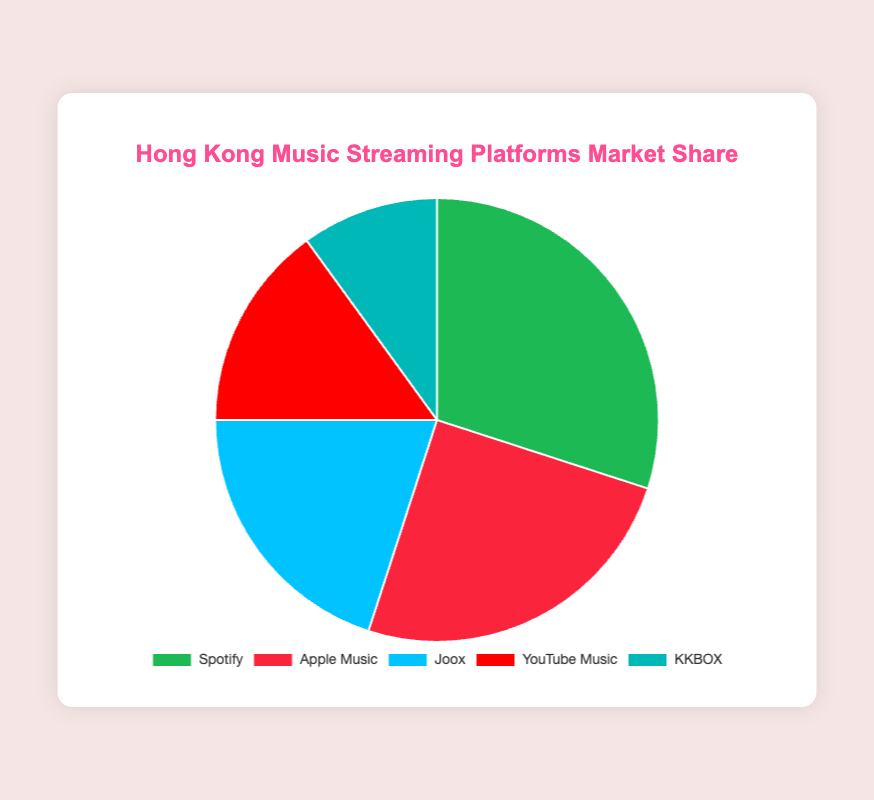What is the market share of Spotify? The pie chart shows the market share percentages for different music streaming platforms. Locate Spotify in the legend or chart, which shows a 30% market share.
Answer: 30% Which platform has the smallest market share, and what is it? Identify each platform's market share from the pie chart and compare them. KKBOX has the smallest market share at 10%.
Answer: KKBOX, 10% How much more market share does Spotify have compared to YouTube Music? Find the market shares for Spotify (30%) and YouTube Music (15%), then calculate the difference: 30% - 15% = 15%.
Answer: 15% What is the total market share of Joox and KKBOX combined? Add Joox's market share (20%) and KKBOX's market share (10%): 20% + 10% = 30%.
Answer: 30% Which platform has the second-largest market share, and what is it? From the pie chart, observe the market shares in descending order. Apple Music has the second-largest share at 25%.
Answer: Apple Music, 25% Which two platforms have a combined market share equal to Spotify's? Find data points that sum to Spotify's 30%. Apple Music (25%) and KKBOX (10%) together have a 30% share.
Answer: Apple Music and KKBOX How does the market share of Apple Music compare to that of Joox? Compare the market shares given: Apple Music (25%) is greater than Joox (20%).
Answer: Apple Music > Joox What is the average market share of the five platforms? Sum the market shares (30% + 25% + 20% + 15% + 10%) = 100%, then divide by 5: 100% / 5 = 20%.
Answer: 20% What color represents YouTube Music in the pie chart? Observe the legend or the pie chart itself to identify the color associated with YouTube Music. It is red.
Answer: Red 